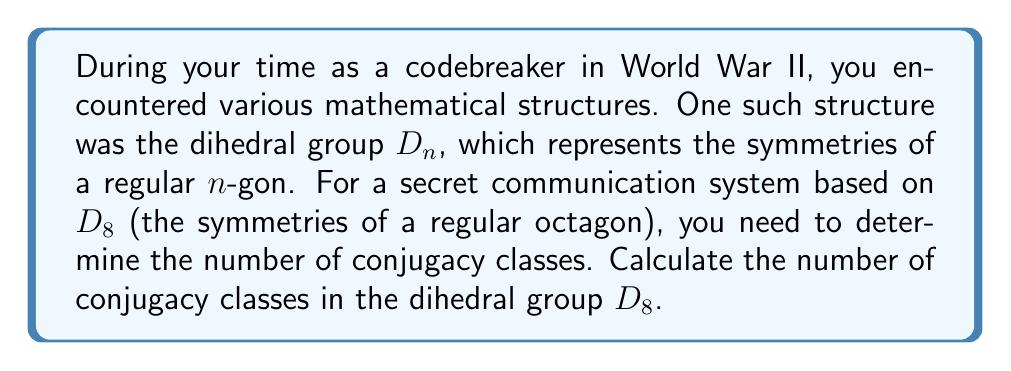Give your solution to this math problem. To calculate the number of conjugacy classes in $D_8$, we'll follow these steps:

1) First, recall the structure of $D_8$:
   - It has $2n = 16$ elements
   - It consists of $n = 8$ rotations (including the identity) and $n = 8$ reflections

2) In $D_n$, there are always three types of conjugacy classes:
   a) The identity element {$e$} (always its own class)
   b) Classes of rotations
   c) Classes of reflections

3) For the rotations:
   - If $n$ is even (which it is in this case), rotations by $k$ and $n-k$ are conjugate
   - The rotation by $n/2 = 4$ is in its own class
   - So we have $1 + (n-2)/2 = 1 + 3 = 4$ classes of rotations (including the identity)

4) For the reflections:
   - If $n$ is even, there are two conjugacy classes of reflections:
     i) Reflections through vertices
     ii) Reflections through edges

5) Therefore, the total number of conjugacy classes is:
   $1$ (identity) $+ 3$ (non-identity rotation classes) $+ 2$ (reflection classes) $= 6$

This result can be generalized: for $D_n$ with even $n$, the number of conjugacy classes is always $n/2 + 3$.
Answer: The dihedral group $D_8$ has 6 conjugacy classes. 